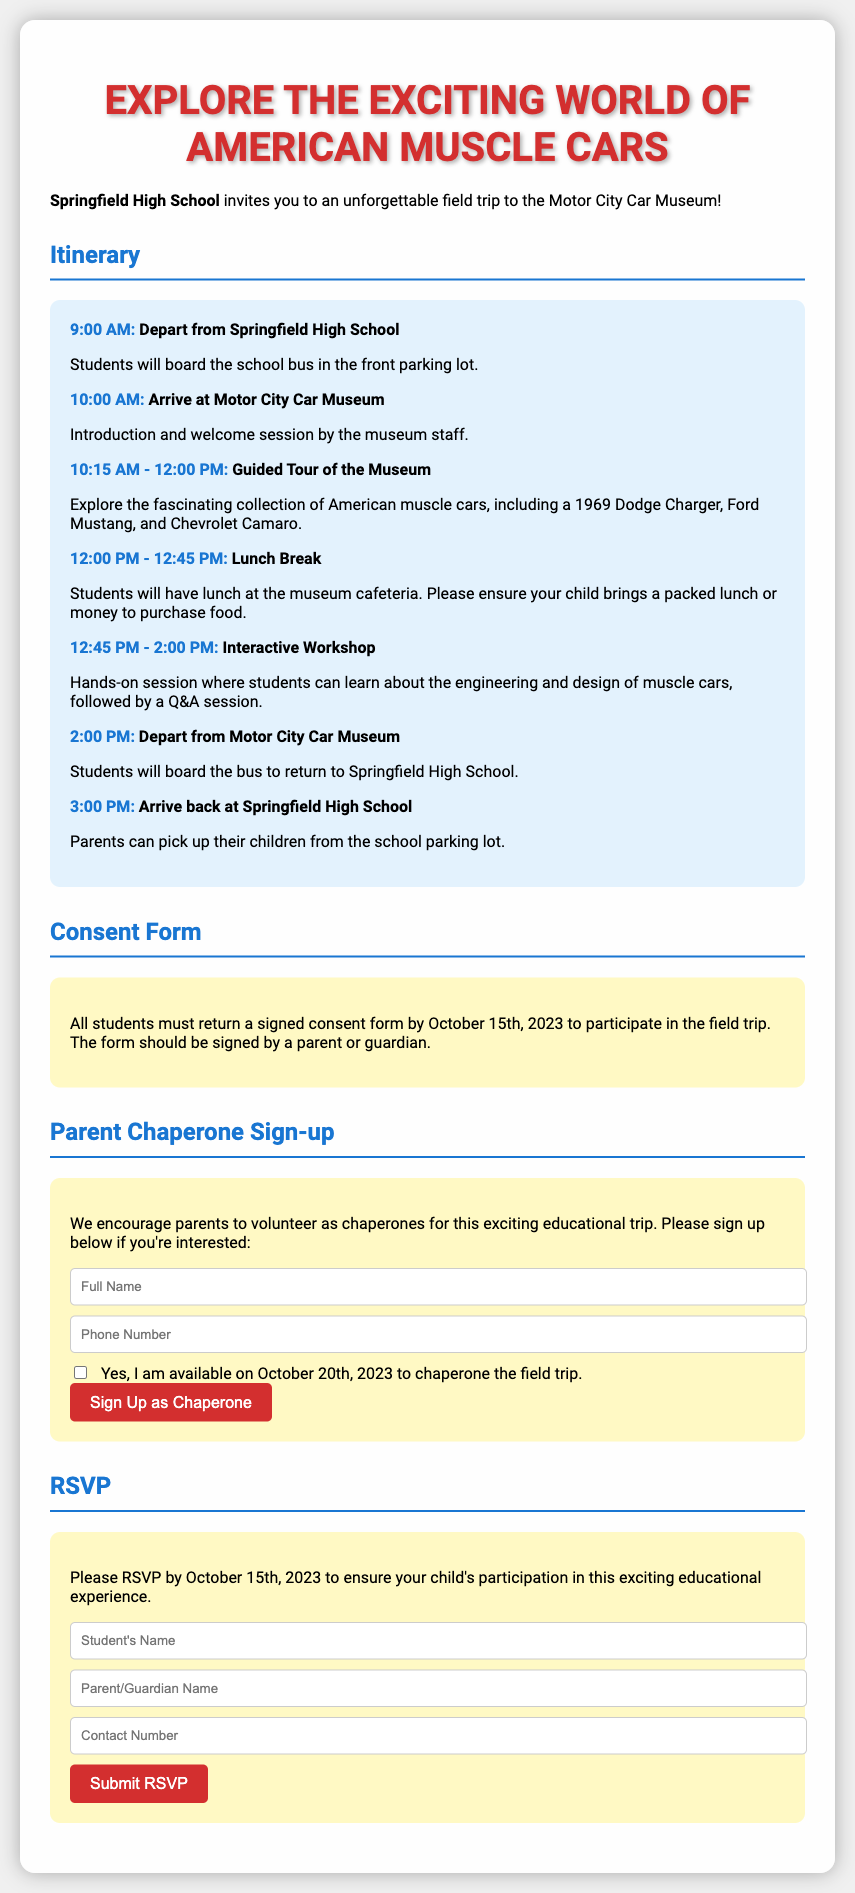What is the departure time from Springfield High School? The departure time is explicitly stated in the itinerary section of the document.
Answer: 9:00 AM What is required to participate in the field trip? The document specifies that a signed consent form is required to participate.
Answer: Signed consent form When is the RSVP deadline? The RSVP deadline is mentioned in the RSVP section under the participation details.
Answer: October 15th, 2023 What activity takes place from 10:15 AM to 12:00 PM? The itinerary outlines the activities scheduled during this time frame, requiring synthesis of details.
Answer: Guided Tour of the Museum Who can sign up to be a chaperone? The document encourages certain individuals to volunteer for a specific role related to the trip.
Answer: Parents What must a parent do to volunteer as a chaperone? The chaperone section describes the necessary action for volunteers in the form provided.
Answer: Sign up How long is the lunch break scheduled for? The duration of the lunch break can be derived from the itinerary section.
Answer: 45 minutes What famous car is specifically mentioned in the museum's collection? The document lists various notable vehicles, enabling identification of one.
Answer: 1969 Dodge Charger What contact information is needed in the RSVP form? The RSVP details outline necessary data to formulate the response.
Answer: Contact Number 